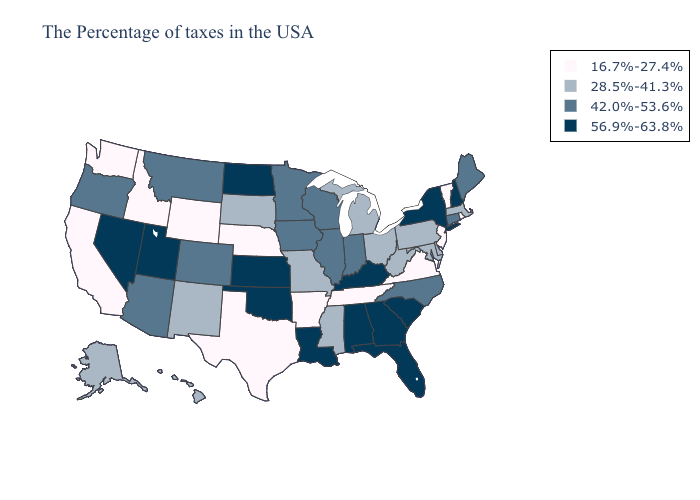Name the states that have a value in the range 56.9%-63.8%?
Quick response, please. New Hampshire, New York, South Carolina, Florida, Georgia, Kentucky, Alabama, Louisiana, Kansas, Oklahoma, North Dakota, Utah, Nevada. Does Alaska have the lowest value in the West?
Write a very short answer. No. Name the states that have a value in the range 28.5%-41.3%?
Write a very short answer. Massachusetts, Delaware, Maryland, Pennsylvania, West Virginia, Ohio, Michigan, Mississippi, Missouri, South Dakota, New Mexico, Alaska, Hawaii. Does Nebraska have the lowest value in the MidWest?
Quick response, please. Yes. Does Arkansas have the lowest value in the South?
Be succinct. Yes. Name the states that have a value in the range 56.9%-63.8%?
Give a very brief answer. New Hampshire, New York, South Carolina, Florida, Georgia, Kentucky, Alabama, Louisiana, Kansas, Oklahoma, North Dakota, Utah, Nevada. Does the map have missing data?
Quick response, please. No. What is the highest value in the USA?
Be succinct. 56.9%-63.8%. Name the states that have a value in the range 56.9%-63.8%?
Quick response, please. New Hampshire, New York, South Carolina, Florida, Georgia, Kentucky, Alabama, Louisiana, Kansas, Oklahoma, North Dakota, Utah, Nevada. What is the value of Maryland?
Concise answer only. 28.5%-41.3%. What is the value of Mississippi?
Write a very short answer. 28.5%-41.3%. Does Colorado have a lower value than Nevada?
Quick response, please. Yes. Name the states that have a value in the range 56.9%-63.8%?
Quick response, please. New Hampshire, New York, South Carolina, Florida, Georgia, Kentucky, Alabama, Louisiana, Kansas, Oklahoma, North Dakota, Utah, Nevada. What is the value of Nevada?
Concise answer only. 56.9%-63.8%. Does Nebraska have the lowest value in the MidWest?
Short answer required. Yes. 